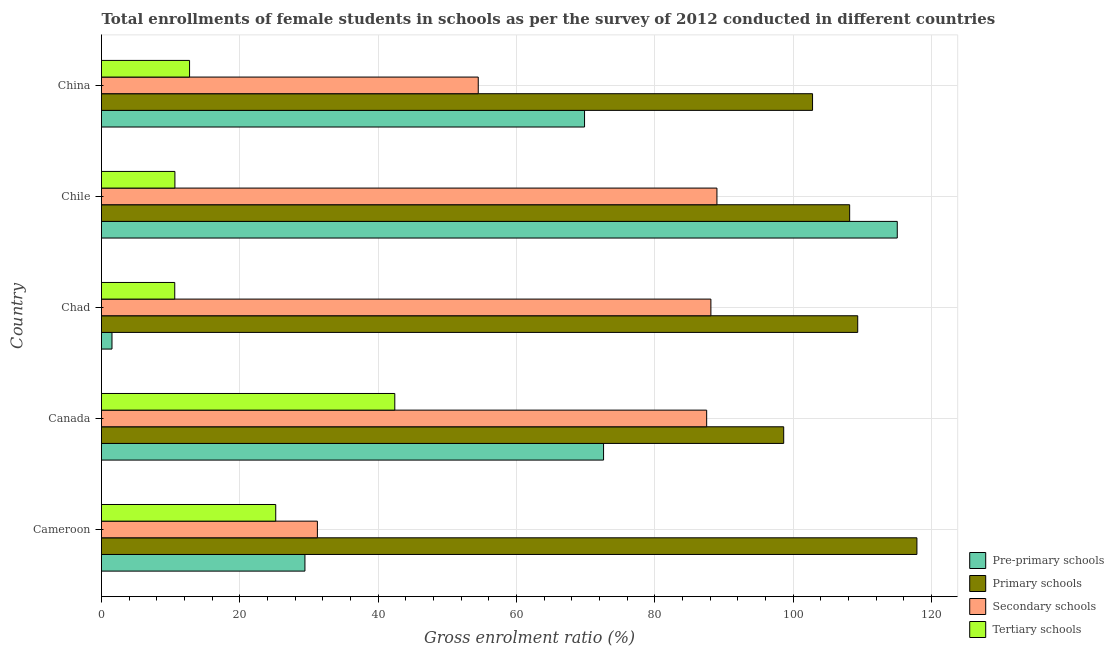How many different coloured bars are there?
Make the answer very short. 4. Are the number of bars on each tick of the Y-axis equal?
Provide a succinct answer. Yes. How many bars are there on the 2nd tick from the top?
Provide a short and direct response. 4. How many bars are there on the 3rd tick from the bottom?
Ensure brevity in your answer.  4. What is the label of the 3rd group of bars from the top?
Offer a terse response. Chad. In how many cases, is the number of bars for a given country not equal to the number of legend labels?
Your answer should be compact. 0. What is the gross enrolment ratio(female) in primary schools in Cameroon?
Make the answer very short. 117.89. Across all countries, what is the maximum gross enrolment ratio(female) in tertiary schools?
Make the answer very short. 42.4. Across all countries, what is the minimum gross enrolment ratio(female) in pre-primary schools?
Ensure brevity in your answer.  1.52. In which country was the gross enrolment ratio(female) in primary schools maximum?
Make the answer very short. Cameroon. In which country was the gross enrolment ratio(female) in secondary schools minimum?
Your answer should be compact. Cameroon. What is the total gross enrolment ratio(female) in pre-primary schools in the graph?
Offer a terse response. 288.39. What is the difference between the gross enrolment ratio(female) in secondary schools in Canada and that in Chad?
Your answer should be compact. -0.61. What is the difference between the gross enrolment ratio(female) in primary schools in Canada and the gross enrolment ratio(female) in pre-primary schools in Chad?
Provide a succinct answer. 97.11. What is the average gross enrolment ratio(female) in tertiary schools per country?
Ensure brevity in your answer.  20.3. What is the difference between the gross enrolment ratio(female) in secondary schools and gross enrolment ratio(female) in tertiary schools in Cameroon?
Offer a very short reply. 6.02. What is the ratio of the gross enrolment ratio(female) in pre-primary schools in Canada to that in Chad?
Offer a very short reply. 47.88. Is the gross enrolment ratio(female) in secondary schools in Chile less than that in China?
Make the answer very short. No. What is the difference between the highest and the second highest gross enrolment ratio(female) in pre-primary schools?
Your answer should be compact. 42.46. What is the difference between the highest and the lowest gross enrolment ratio(female) in tertiary schools?
Give a very brief answer. 31.81. In how many countries, is the gross enrolment ratio(female) in primary schools greater than the average gross enrolment ratio(female) in primary schools taken over all countries?
Provide a succinct answer. 3. Is the sum of the gross enrolment ratio(female) in tertiary schools in Cameroon and Chile greater than the maximum gross enrolment ratio(female) in secondary schools across all countries?
Provide a succinct answer. No. What does the 2nd bar from the top in Canada represents?
Your answer should be very brief. Secondary schools. What does the 2nd bar from the bottom in Canada represents?
Provide a succinct answer. Primary schools. Is it the case that in every country, the sum of the gross enrolment ratio(female) in pre-primary schools and gross enrolment ratio(female) in primary schools is greater than the gross enrolment ratio(female) in secondary schools?
Ensure brevity in your answer.  Yes. How many bars are there?
Provide a succinct answer. 20. How many countries are there in the graph?
Provide a short and direct response. 5. Are the values on the major ticks of X-axis written in scientific E-notation?
Offer a very short reply. No. Does the graph contain any zero values?
Provide a succinct answer. No. Does the graph contain grids?
Your response must be concise. Yes. How many legend labels are there?
Your answer should be compact. 4. How are the legend labels stacked?
Provide a short and direct response. Vertical. What is the title of the graph?
Offer a terse response. Total enrollments of female students in schools as per the survey of 2012 conducted in different countries. What is the label or title of the Y-axis?
Give a very brief answer. Country. What is the Gross enrolment ratio (%) of Pre-primary schools in Cameroon?
Your answer should be compact. 29.41. What is the Gross enrolment ratio (%) of Primary schools in Cameroon?
Your response must be concise. 117.89. What is the Gross enrolment ratio (%) of Secondary schools in Cameroon?
Your response must be concise. 31.21. What is the Gross enrolment ratio (%) of Tertiary schools in Cameroon?
Your answer should be compact. 25.19. What is the Gross enrolment ratio (%) of Pre-primary schools in Canada?
Ensure brevity in your answer.  72.58. What is the Gross enrolment ratio (%) in Primary schools in Canada?
Your response must be concise. 98.63. What is the Gross enrolment ratio (%) of Secondary schools in Canada?
Your response must be concise. 87.49. What is the Gross enrolment ratio (%) in Tertiary schools in Canada?
Keep it short and to the point. 42.4. What is the Gross enrolment ratio (%) in Pre-primary schools in Chad?
Make the answer very short. 1.52. What is the Gross enrolment ratio (%) of Primary schools in Chad?
Your answer should be compact. 109.33. What is the Gross enrolment ratio (%) of Secondary schools in Chad?
Ensure brevity in your answer.  88.1. What is the Gross enrolment ratio (%) in Tertiary schools in Chad?
Offer a terse response. 10.59. What is the Gross enrolment ratio (%) of Pre-primary schools in Chile?
Give a very brief answer. 115.05. What is the Gross enrolment ratio (%) in Primary schools in Chile?
Your response must be concise. 108.16. What is the Gross enrolment ratio (%) of Secondary schools in Chile?
Make the answer very short. 88.97. What is the Gross enrolment ratio (%) of Tertiary schools in Chile?
Ensure brevity in your answer.  10.61. What is the Gross enrolment ratio (%) in Pre-primary schools in China?
Your answer should be very brief. 69.83. What is the Gross enrolment ratio (%) of Primary schools in China?
Offer a terse response. 102.8. What is the Gross enrolment ratio (%) in Secondary schools in China?
Keep it short and to the point. 54.47. What is the Gross enrolment ratio (%) in Tertiary schools in China?
Provide a succinct answer. 12.73. Across all countries, what is the maximum Gross enrolment ratio (%) of Pre-primary schools?
Provide a succinct answer. 115.05. Across all countries, what is the maximum Gross enrolment ratio (%) in Primary schools?
Provide a succinct answer. 117.89. Across all countries, what is the maximum Gross enrolment ratio (%) in Secondary schools?
Your answer should be very brief. 88.97. Across all countries, what is the maximum Gross enrolment ratio (%) of Tertiary schools?
Your response must be concise. 42.4. Across all countries, what is the minimum Gross enrolment ratio (%) in Pre-primary schools?
Ensure brevity in your answer.  1.52. Across all countries, what is the minimum Gross enrolment ratio (%) of Primary schools?
Your response must be concise. 98.63. Across all countries, what is the minimum Gross enrolment ratio (%) of Secondary schools?
Offer a terse response. 31.21. Across all countries, what is the minimum Gross enrolment ratio (%) of Tertiary schools?
Your answer should be very brief. 10.59. What is the total Gross enrolment ratio (%) in Pre-primary schools in the graph?
Keep it short and to the point. 288.39. What is the total Gross enrolment ratio (%) of Primary schools in the graph?
Provide a succinct answer. 536.8. What is the total Gross enrolment ratio (%) in Secondary schools in the graph?
Provide a succinct answer. 350.24. What is the total Gross enrolment ratio (%) of Tertiary schools in the graph?
Provide a succinct answer. 101.52. What is the difference between the Gross enrolment ratio (%) in Pre-primary schools in Cameroon and that in Canada?
Your answer should be compact. -43.17. What is the difference between the Gross enrolment ratio (%) in Primary schools in Cameroon and that in Canada?
Your response must be concise. 19.26. What is the difference between the Gross enrolment ratio (%) in Secondary schools in Cameroon and that in Canada?
Provide a succinct answer. -56.28. What is the difference between the Gross enrolment ratio (%) in Tertiary schools in Cameroon and that in Canada?
Ensure brevity in your answer.  -17.21. What is the difference between the Gross enrolment ratio (%) of Pre-primary schools in Cameroon and that in Chad?
Provide a short and direct response. 27.9. What is the difference between the Gross enrolment ratio (%) of Primary schools in Cameroon and that in Chad?
Your response must be concise. 8.56. What is the difference between the Gross enrolment ratio (%) in Secondary schools in Cameroon and that in Chad?
Offer a terse response. -56.89. What is the difference between the Gross enrolment ratio (%) in Tertiary schools in Cameroon and that in Chad?
Give a very brief answer. 14.6. What is the difference between the Gross enrolment ratio (%) in Pre-primary schools in Cameroon and that in Chile?
Your answer should be compact. -85.63. What is the difference between the Gross enrolment ratio (%) of Primary schools in Cameroon and that in Chile?
Give a very brief answer. 9.73. What is the difference between the Gross enrolment ratio (%) of Secondary schools in Cameroon and that in Chile?
Provide a short and direct response. -57.76. What is the difference between the Gross enrolment ratio (%) of Tertiary schools in Cameroon and that in Chile?
Your answer should be very brief. 14.58. What is the difference between the Gross enrolment ratio (%) of Pre-primary schools in Cameroon and that in China?
Your answer should be compact. -40.42. What is the difference between the Gross enrolment ratio (%) in Primary schools in Cameroon and that in China?
Give a very brief answer. 15.09. What is the difference between the Gross enrolment ratio (%) of Secondary schools in Cameroon and that in China?
Your answer should be very brief. -23.25. What is the difference between the Gross enrolment ratio (%) in Tertiary schools in Cameroon and that in China?
Provide a succinct answer. 12.46. What is the difference between the Gross enrolment ratio (%) in Pre-primary schools in Canada and that in Chad?
Your answer should be very brief. 71.07. What is the difference between the Gross enrolment ratio (%) of Primary schools in Canada and that in Chad?
Your answer should be very brief. -10.7. What is the difference between the Gross enrolment ratio (%) in Secondary schools in Canada and that in Chad?
Your response must be concise. -0.61. What is the difference between the Gross enrolment ratio (%) of Tertiary schools in Canada and that in Chad?
Keep it short and to the point. 31.81. What is the difference between the Gross enrolment ratio (%) of Pre-primary schools in Canada and that in Chile?
Offer a terse response. -42.46. What is the difference between the Gross enrolment ratio (%) of Primary schools in Canada and that in Chile?
Offer a very short reply. -9.53. What is the difference between the Gross enrolment ratio (%) in Secondary schools in Canada and that in Chile?
Your answer should be very brief. -1.48. What is the difference between the Gross enrolment ratio (%) of Tertiary schools in Canada and that in Chile?
Keep it short and to the point. 31.79. What is the difference between the Gross enrolment ratio (%) in Pre-primary schools in Canada and that in China?
Keep it short and to the point. 2.75. What is the difference between the Gross enrolment ratio (%) in Primary schools in Canada and that in China?
Provide a short and direct response. -4.17. What is the difference between the Gross enrolment ratio (%) in Secondary schools in Canada and that in China?
Your response must be concise. 33.02. What is the difference between the Gross enrolment ratio (%) in Tertiary schools in Canada and that in China?
Your answer should be compact. 29.67. What is the difference between the Gross enrolment ratio (%) in Pre-primary schools in Chad and that in Chile?
Provide a succinct answer. -113.53. What is the difference between the Gross enrolment ratio (%) of Primary schools in Chad and that in Chile?
Offer a terse response. 1.17. What is the difference between the Gross enrolment ratio (%) of Secondary schools in Chad and that in Chile?
Offer a very short reply. -0.87. What is the difference between the Gross enrolment ratio (%) of Tertiary schools in Chad and that in Chile?
Give a very brief answer. -0.02. What is the difference between the Gross enrolment ratio (%) in Pre-primary schools in Chad and that in China?
Make the answer very short. -68.32. What is the difference between the Gross enrolment ratio (%) in Primary schools in Chad and that in China?
Your answer should be very brief. 6.53. What is the difference between the Gross enrolment ratio (%) in Secondary schools in Chad and that in China?
Provide a short and direct response. 33.63. What is the difference between the Gross enrolment ratio (%) of Tertiary schools in Chad and that in China?
Your response must be concise. -2.14. What is the difference between the Gross enrolment ratio (%) in Pre-primary schools in Chile and that in China?
Provide a succinct answer. 45.21. What is the difference between the Gross enrolment ratio (%) in Primary schools in Chile and that in China?
Offer a very short reply. 5.36. What is the difference between the Gross enrolment ratio (%) of Secondary schools in Chile and that in China?
Provide a short and direct response. 34.51. What is the difference between the Gross enrolment ratio (%) in Tertiary schools in Chile and that in China?
Offer a very short reply. -2.12. What is the difference between the Gross enrolment ratio (%) of Pre-primary schools in Cameroon and the Gross enrolment ratio (%) of Primary schools in Canada?
Provide a short and direct response. -69.22. What is the difference between the Gross enrolment ratio (%) in Pre-primary schools in Cameroon and the Gross enrolment ratio (%) in Secondary schools in Canada?
Your response must be concise. -58.08. What is the difference between the Gross enrolment ratio (%) in Pre-primary schools in Cameroon and the Gross enrolment ratio (%) in Tertiary schools in Canada?
Give a very brief answer. -12.99. What is the difference between the Gross enrolment ratio (%) of Primary schools in Cameroon and the Gross enrolment ratio (%) of Secondary schools in Canada?
Ensure brevity in your answer.  30.4. What is the difference between the Gross enrolment ratio (%) of Primary schools in Cameroon and the Gross enrolment ratio (%) of Tertiary schools in Canada?
Ensure brevity in your answer.  75.48. What is the difference between the Gross enrolment ratio (%) of Secondary schools in Cameroon and the Gross enrolment ratio (%) of Tertiary schools in Canada?
Provide a short and direct response. -11.19. What is the difference between the Gross enrolment ratio (%) of Pre-primary schools in Cameroon and the Gross enrolment ratio (%) of Primary schools in Chad?
Keep it short and to the point. -79.92. What is the difference between the Gross enrolment ratio (%) in Pre-primary schools in Cameroon and the Gross enrolment ratio (%) in Secondary schools in Chad?
Provide a succinct answer. -58.69. What is the difference between the Gross enrolment ratio (%) in Pre-primary schools in Cameroon and the Gross enrolment ratio (%) in Tertiary schools in Chad?
Provide a succinct answer. 18.82. What is the difference between the Gross enrolment ratio (%) in Primary schools in Cameroon and the Gross enrolment ratio (%) in Secondary schools in Chad?
Your answer should be very brief. 29.79. What is the difference between the Gross enrolment ratio (%) in Primary schools in Cameroon and the Gross enrolment ratio (%) in Tertiary schools in Chad?
Give a very brief answer. 107.3. What is the difference between the Gross enrolment ratio (%) of Secondary schools in Cameroon and the Gross enrolment ratio (%) of Tertiary schools in Chad?
Give a very brief answer. 20.62. What is the difference between the Gross enrolment ratio (%) in Pre-primary schools in Cameroon and the Gross enrolment ratio (%) in Primary schools in Chile?
Your answer should be very brief. -78.75. What is the difference between the Gross enrolment ratio (%) in Pre-primary schools in Cameroon and the Gross enrolment ratio (%) in Secondary schools in Chile?
Your response must be concise. -59.56. What is the difference between the Gross enrolment ratio (%) in Pre-primary schools in Cameroon and the Gross enrolment ratio (%) in Tertiary schools in Chile?
Ensure brevity in your answer.  18.8. What is the difference between the Gross enrolment ratio (%) in Primary schools in Cameroon and the Gross enrolment ratio (%) in Secondary schools in Chile?
Give a very brief answer. 28.91. What is the difference between the Gross enrolment ratio (%) of Primary schools in Cameroon and the Gross enrolment ratio (%) of Tertiary schools in Chile?
Provide a succinct answer. 107.28. What is the difference between the Gross enrolment ratio (%) of Secondary schools in Cameroon and the Gross enrolment ratio (%) of Tertiary schools in Chile?
Your answer should be compact. 20.6. What is the difference between the Gross enrolment ratio (%) of Pre-primary schools in Cameroon and the Gross enrolment ratio (%) of Primary schools in China?
Make the answer very short. -73.39. What is the difference between the Gross enrolment ratio (%) in Pre-primary schools in Cameroon and the Gross enrolment ratio (%) in Secondary schools in China?
Ensure brevity in your answer.  -25.05. What is the difference between the Gross enrolment ratio (%) of Pre-primary schools in Cameroon and the Gross enrolment ratio (%) of Tertiary schools in China?
Your answer should be compact. 16.68. What is the difference between the Gross enrolment ratio (%) in Primary schools in Cameroon and the Gross enrolment ratio (%) in Secondary schools in China?
Your answer should be very brief. 63.42. What is the difference between the Gross enrolment ratio (%) in Primary schools in Cameroon and the Gross enrolment ratio (%) in Tertiary schools in China?
Offer a very short reply. 105.16. What is the difference between the Gross enrolment ratio (%) in Secondary schools in Cameroon and the Gross enrolment ratio (%) in Tertiary schools in China?
Your response must be concise. 18.48. What is the difference between the Gross enrolment ratio (%) of Pre-primary schools in Canada and the Gross enrolment ratio (%) of Primary schools in Chad?
Offer a terse response. -36.74. What is the difference between the Gross enrolment ratio (%) of Pre-primary schools in Canada and the Gross enrolment ratio (%) of Secondary schools in Chad?
Keep it short and to the point. -15.52. What is the difference between the Gross enrolment ratio (%) of Pre-primary schools in Canada and the Gross enrolment ratio (%) of Tertiary schools in Chad?
Offer a very short reply. 61.99. What is the difference between the Gross enrolment ratio (%) of Primary schools in Canada and the Gross enrolment ratio (%) of Secondary schools in Chad?
Your answer should be very brief. 10.53. What is the difference between the Gross enrolment ratio (%) in Primary schools in Canada and the Gross enrolment ratio (%) in Tertiary schools in Chad?
Offer a very short reply. 88.04. What is the difference between the Gross enrolment ratio (%) of Secondary schools in Canada and the Gross enrolment ratio (%) of Tertiary schools in Chad?
Your answer should be very brief. 76.9. What is the difference between the Gross enrolment ratio (%) in Pre-primary schools in Canada and the Gross enrolment ratio (%) in Primary schools in Chile?
Your answer should be compact. -35.58. What is the difference between the Gross enrolment ratio (%) of Pre-primary schools in Canada and the Gross enrolment ratio (%) of Secondary schools in Chile?
Offer a very short reply. -16.39. What is the difference between the Gross enrolment ratio (%) of Pre-primary schools in Canada and the Gross enrolment ratio (%) of Tertiary schools in Chile?
Provide a short and direct response. 61.97. What is the difference between the Gross enrolment ratio (%) of Primary schools in Canada and the Gross enrolment ratio (%) of Secondary schools in Chile?
Your answer should be compact. 9.65. What is the difference between the Gross enrolment ratio (%) in Primary schools in Canada and the Gross enrolment ratio (%) in Tertiary schools in Chile?
Offer a very short reply. 88.02. What is the difference between the Gross enrolment ratio (%) in Secondary schools in Canada and the Gross enrolment ratio (%) in Tertiary schools in Chile?
Make the answer very short. 76.88. What is the difference between the Gross enrolment ratio (%) of Pre-primary schools in Canada and the Gross enrolment ratio (%) of Primary schools in China?
Provide a short and direct response. -30.21. What is the difference between the Gross enrolment ratio (%) in Pre-primary schools in Canada and the Gross enrolment ratio (%) in Secondary schools in China?
Provide a short and direct response. 18.12. What is the difference between the Gross enrolment ratio (%) of Pre-primary schools in Canada and the Gross enrolment ratio (%) of Tertiary schools in China?
Provide a succinct answer. 59.85. What is the difference between the Gross enrolment ratio (%) of Primary schools in Canada and the Gross enrolment ratio (%) of Secondary schools in China?
Your answer should be very brief. 44.16. What is the difference between the Gross enrolment ratio (%) of Primary schools in Canada and the Gross enrolment ratio (%) of Tertiary schools in China?
Keep it short and to the point. 85.9. What is the difference between the Gross enrolment ratio (%) in Secondary schools in Canada and the Gross enrolment ratio (%) in Tertiary schools in China?
Your answer should be very brief. 74.76. What is the difference between the Gross enrolment ratio (%) in Pre-primary schools in Chad and the Gross enrolment ratio (%) in Primary schools in Chile?
Your response must be concise. -106.65. What is the difference between the Gross enrolment ratio (%) of Pre-primary schools in Chad and the Gross enrolment ratio (%) of Secondary schools in Chile?
Your answer should be compact. -87.46. What is the difference between the Gross enrolment ratio (%) in Pre-primary schools in Chad and the Gross enrolment ratio (%) in Tertiary schools in Chile?
Your answer should be compact. -9.1. What is the difference between the Gross enrolment ratio (%) in Primary schools in Chad and the Gross enrolment ratio (%) in Secondary schools in Chile?
Make the answer very short. 20.35. What is the difference between the Gross enrolment ratio (%) of Primary schools in Chad and the Gross enrolment ratio (%) of Tertiary schools in Chile?
Offer a very short reply. 98.72. What is the difference between the Gross enrolment ratio (%) in Secondary schools in Chad and the Gross enrolment ratio (%) in Tertiary schools in Chile?
Offer a very short reply. 77.49. What is the difference between the Gross enrolment ratio (%) of Pre-primary schools in Chad and the Gross enrolment ratio (%) of Primary schools in China?
Your response must be concise. -101.28. What is the difference between the Gross enrolment ratio (%) in Pre-primary schools in Chad and the Gross enrolment ratio (%) in Secondary schools in China?
Your response must be concise. -52.95. What is the difference between the Gross enrolment ratio (%) of Pre-primary schools in Chad and the Gross enrolment ratio (%) of Tertiary schools in China?
Your answer should be compact. -11.22. What is the difference between the Gross enrolment ratio (%) in Primary schools in Chad and the Gross enrolment ratio (%) in Secondary schools in China?
Your response must be concise. 54.86. What is the difference between the Gross enrolment ratio (%) in Primary schools in Chad and the Gross enrolment ratio (%) in Tertiary schools in China?
Keep it short and to the point. 96.6. What is the difference between the Gross enrolment ratio (%) in Secondary schools in Chad and the Gross enrolment ratio (%) in Tertiary schools in China?
Give a very brief answer. 75.37. What is the difference between the Gross enrolment ratio (%) in Pre-primary schools in Chile and the Gross enrolment ratio (%) in Primary schools in China?
Give a very brief answer. 12.25. What is the difference between the Gross enrolment ratio (%) in Pre-primary schools in Chile and the Gross enrolment ratio (%) in Secondary schools in China?
Your response must be concise. 60.58. What is the difference between the Gross enrolment ratio (%) in Pre-primary schools in Chile and the Gross enrolment ratio (%) in Tertiary schools in China?
Offer a very short reply. 102.31. What is the difference between the Gross enrolment ratio (%) of Primary schools in Chile and the Gross enrolment ratio (%) of Secondary schools in China?
Make the answer very short. 53.69. What is the difference between the Gross enrolment ratio (%) in Primary schools in Chile and the Gross enrolment ratio (%) in Tertiary schools in China?
Your response must be concise. 95.43. What is the difference between the Gross enrolment ratio (%) of Secondary schools in Chile and the Gross enrolment ratio (%) of Tertiary schools in China?
Keep it short and to the point. 76.24. What is the average Gross enrolment ratio (%) in Pre-primary schools per country?
Ensure brevity in your answer.  57.68. What is the average Gross enrolment ratio (%) of Primary schools per country?
Give a very brief answer. 107.36. What is the average Gross enrolment ratio (%) of Secondary schools per country?
Your answer should be very brief. 70.05. What is the average Gross enrolment ratio (%) in Tertiary schools per country?
Your answer should be compact. 20.3. What is the difference between the Gross enrolment ratio (%) of Pre-primary schools and Gross enrolment ratio (%) of Primary schools in Cameroon?
Your response must be concise. -88.48. What is the difference between the Gross enrolment ratio (%) in Pre-primary schools and Gross enrolment ratio (%) in Secondary schools in Cameroon?
Offer a terse response. -1.8. What is the difference between the Gross enrolment ratio (%) of Pre-primary schools and Gross enrolment ratio (%) of Tertiary schools in Cameroon?
Keep it short and to the point. 4.22. What is the difference between the Gross enrolment ratio (%) of Primary schools and Gross enrolment ratio (%) of Secondary schools in Cameroon?
Provide a short and direct response. 86.67. What is the difference between the Gross enrolment ratio (%) in Primary schools and Gross enrolment ratio (%) in Tertiary schools in Cameroon?
Provide a succinct answer. 92.7. What is the difference between the Gross enrolment ratio (%) of Secondary schools and Gross enrolment ratio (%) of Tertiary schools in Cameroon?
Keep it short and to the point. 6.02. What is the difference between the Gross enrolment ratio (%) in Pre-primary schools and Gross enrolment ratio (%) in Primary schools in Canada?
Your answer should be very brief. -26.04. What is the difference between the Gross enrolment ratio (%) in Pre-primary schools and Gross enrolment ratio (%) in Secondary schools in Canada?
Provide a succinct answer. -14.91. What is the difference between the Gross enrolment ratio (%) of Pre-primary schools and Gross enrolment ratio (%) of Tertiary schools in Canada?
Ensure brevity in your answer.  30.18. What is the difference between the Gross enrolment ratio (%) of Primary schools and Gross enrolment ratio (%) of Secondary schools in Canada?
Provide a short and direct response. 11.14. What is the difference between the Gross enrolment ratio (%) in Primary schools and Gross enrolment ratio (%) in Tertiary schools in Canada?
Your answer should be compact. 56.23. What is the difference between the Gross enrolment ratio (%) of Secondary schools and Gross enrolment ratio (%) of Tertiary schools in Canada?
Provide a short and direct response. 45.09. What is the difference between the Gross enrolment ratio (%) in Pre-primary schools and Gross enrolment ratio (%) in Primary schools in Chad?
Keep it short and to the point. -107.81. What is the difference between the Gross enrolment ratio (%) in Pre-primary schools and Gross enrolment ratio (%) in Secondary schools in Chad?
Offer a terse response. -86.58. What is the difference between the Gross enrolment ratio (%) in Pre-primary schools and Gross enrolment ratio (%) in Tertiary schools in Chad?
Keep it short and to the point. -9.07. What is the difference between the Gross enrolment ratio (%) in Primary schools and Gross enrolment ratio (%) in Secondary schools in Chad?
Give a very brief answer. 21.23. What is the difference between the Gross enrolment ratio (%) of Primary schools and Gross enrolment ratio (%) of Tertiary schools in Chad?
Ensure brevity in your answer.  98.74. What is the difference between the Gross enrolment ratio (%) in Secondary schools and Gross enrolment ratio (%) in Tertiary schools in Chad?
Make the answer very short. 77.51. What is the difference between the Gross enrolment ratio (%) in Pre-primary schools and Gross enrolment ratio (%) in Primary schools in Chile?
Your answer should be very brief. 6.88. What is the difference between the Gross enrolment ratio (%) in Pre-primary schools and Gross enrolment ratio (%) in Secondary schools in Chile?
Your answer should be compact. 26.07. What is the difference between the Gross enrolment ratio (%) in Pre-primary schools and Gross enrolment ratio (%) in Tertiary schools in Chile?
Offer a very short reply. 104.43. What is the difference between the Gross enrolment ratio (%) in Primary schools and Gross enrolment ratio (%) in Secondary schools in Chile?
Your answer should be very brief. 19.19. What is the difference between the Gross enrolment ratio (%) in Primary schools and Gross enrolment ratio (%) in Tertiary schools in Chile?
Keep it short and to the point. 97.55. What is the difference between the Gross enrolment ratio (%) in Secondary schools and Gross enrolment ratio (%) in Tertiary schools in Chile?
Give a very brief answer. 78.36. What is the difference between the Gross enrolment ratio (%) in Pre-primary schools and Gross enrolment ratio (%) in Primary schools in China?
Ensure brevity in your answer.  -32.96. What is the difference between the Gross enrolment ratio (%) of Pre-primary schools and Gross enrolment ratio (%) of Secondary schools in China?
Your answer should be compact. 15.37. What is the difference between the Gross enrolment ratio (%) of Pre-primary schools and Gross enrolment ratio (%) of Tertiary schools in China?
Your response must be concise. 57.1. What is the difference between the Gross enrolment ratio (%) of Primary schools and Gross enrolment ratio (%) of Secondary schools in China?
Provide a succinct answer. 48.33. What is the difference between the Gross enrolment ratio (%) in Primary schools and Gross enrolment ratio (%) in Tertiary schools in China?
Your answer should be very brief. 90.07. What is the difference between the Gross enrolment ratio (%) of Secondary schools and Gross enrolment ratio (%) of Tertiary schools in China?
Your answer should be compact. 41.73. What is the ratio of the Gross enrolment ratio (%) of Pre-primary schools in Cameroon to that in Canada?
Your response must be concise. 0.41. What is the ratio of the Gross enrolment ratio (%) of Primary schools in Cameroon to that in Canada?
Make the answer very short. 1.2. What is the ratio of the Gross enrolment ratio (%) in Secondary schools in Cameroon to that in Canada?
Your answer should be compact. 0.36. What is the ratio of the Gross enrolment ratio (%) in Tertiary schools in Cameroon to that in Canada?
Provide a short and direct response. 0.59. What is the ratio of the Gross enrolment ratio (%) in Pre-primary schools in Cameroon to that in Chad?
Provide a short and direct response. 19.4. What is the ratio of the Gross enrolment ratio (%) of Primary schools in Cameroon to that in Chad?
Make the answer very short. 1.08. What is the ratio of the Gross enrolment ratio (%) in Secondary schools in Cameroon to that in Chad?
Your answer should be compact. 0.35. What is the ratio of the Gross enrolment ratio (%) in Tertiary schools in Cameroon to that in Chad?
Your answer should be very brief. 2.38. What is the ratio of the Gross enrolment ratio (%) in Pre-primary schools in Cameroon to that in Chile?
Ensure brevity in your answer.  0.26. What is the ratio of the Gross enrolment ratio (%) of Primary schools in Cameroon to that in Chile?
Provide a succinct answer. 1.09. What is the ratio of the Gross enrolment ratio (%) in Secondary schools in Cameroon to that in Chile?
Provide a succinct answer. 0.35. What is the ratio of the Gross enrolment ratio (%) in Tertiary schools in Cameroon to that in Chile?
Keep it short and to the point. 2.37. What is the ratio of the Gross enrolment ratio (%) of Pre-primary schools in Cameroon to that in China?
Provide a short and direct response. 0.42. What is the ratio of the Gross enrolment ratio (%) in Primary schools in Cameroon to that in China?
Offer a very short reply. 1.15. What is the ratio of the Gross enrolment ratio (%) in Secondary schools in Cameroon to that in China?
Make the answer very short. 0.57. What is the ratio of the Gross enrolment ratio (%) in Tertiary schools in Cameroon to that in China?
Your answer should be compact. 1.98. What is the ratio of the Gross enrolment ratio (%) in Pre-primary schools in Canada to that in Chad?
Make the answer very short. 47.88. What is the ratio of the Gross enrolment ratio (%) in Primary schools in Canada to that in Chad?
Your answer should be compact. 0.9. What is the ratio of the Gross enrolment ratio (%) in Secondary schools in Canada to that in Chad?
Provide a short and direct response. 0.99. What is the ratio of the Gross enrolment ratio (%) of Tertiary schools in Canada to that in Chad?
Keep it short and to the point. 4. What is the ratio of the Gross enrolment ratio (%) in Pre-primary schools in Canada to that in Chile?
Your answer should be compact. 0.63. What is the ratio of the Gross enrolment ratio (%) of Primary schools in Canada to that in Chile?
Your answer should be compact. 0.91. What is the ratio of the Gross enrolment ratio (%) in Secondary schools in Canada to that in Chile?
Your answer should be very brief. 0.98. What is the ratio of the Gross enrolment ratio (%) of Tertiary schools in Canada to that in Chile?
Your response must be concise. 4. What is the ratio of the Gross enrolment ratio (%) of Pre-primary schools in Canada to that in China?
Provide a short and direct response. 1.04. What is the ratio of the Gross enrolment ratio (%) in Primary schools in Canada to that in China?
Provide a short and direct response. 0.96. What is the ratio of the Gross enrolment ratio (%) of Secondary schools in Canada to that in China?
Offer a very short reply. 1.61. What is the ratio of the Gross enrolment ratio (%) in Tertiary schools in Canada to that in China?
Offer a very short reply. 3.33. What is the ratio of the Gross enrolment ratio (%) in Pre-primary schools in Chad to that in Chile?
Ensure brevity in your answer.  0.01. What is the ratio of the Gross enrolment ratio (%) in Primary schools in Chad to that in Chile?
Ensure brevity in your answer.  1.01. What is the ratio of the Gross enrolment ratio (%) in Secondary schools in Chad to that in Chile?
Make the answer very short. 0.99. What is the ratio of the Gross enrolment ratio (%) in Pre-primary schools in Chad to that in China?
Provide a short and direct response. 0.02. What is the ratio of the Gross enrolment ratio (%) in Primary schools in Chad to that in China?
Offer a very short reply. 1.06. What is the ratio of the Gross enrolment ratio (%) in Secondary schools in Chad to that in China?
Offer a very short reply. 1.62. What is the ratio of the Gross enrolment ratio (%) in Tertiary schools in Chad to that in China?
Give a very brief answer. 0.83. What is the ratio of the Gross enrolment ratio (%) in Pre-primary schools in Chile to that in China?
Your response must be concise. 1.65. What is the ratio of the Gross enrolment ratio (%) in Primary schools in Chile to that in China?
Your response must be concise. 1.05. What is the ratio of the Gross enrolment ratio (%) in Secondary schools in Chile to that in China?
Your answer should be compact. 1.63. What is the ratio of the Gross enrolment ratio (%) in Tertiary schools in Chile to that in China?
Offer a very short reply. 0.83. What is the difference between the highest and the second highest Gross enrolment ratio (%) in Pre-primary schools?
Keep it short and to the point. 42.46. What is the difference between the highest and the second highest Gross enrolment ratio (%) in Primary schools?
Provide a short and direct response. 8.56. What is the difference between the highest and the second highest Gross enrolment ratio (%) of Secondary schools?
Keep it short and to the point. 0.87. What is the difference between the highest and the second highest Gross enrolment ratio (%) in Tertiary schools?
Make the answer very short. 17.21. What is the difference between the highest and the lowest Gross enrolment ratio (%) in Pre-primary schools?
Make the answer very short. 113.53. What is the difference between the highest and the lowest Gross enrolment ratio (%) in Primary schools?
Your answer should be compact. 19.26. What is the difference between the highest and the lowest Gross enrolment ratio (%) of Secondary schools?
Your answer should be very brief. 57.76. What is the difference between the highest and the lowest Gross enrolment ratio (%) of Tertiary schools?
Offer a very short reply. 31.81. 